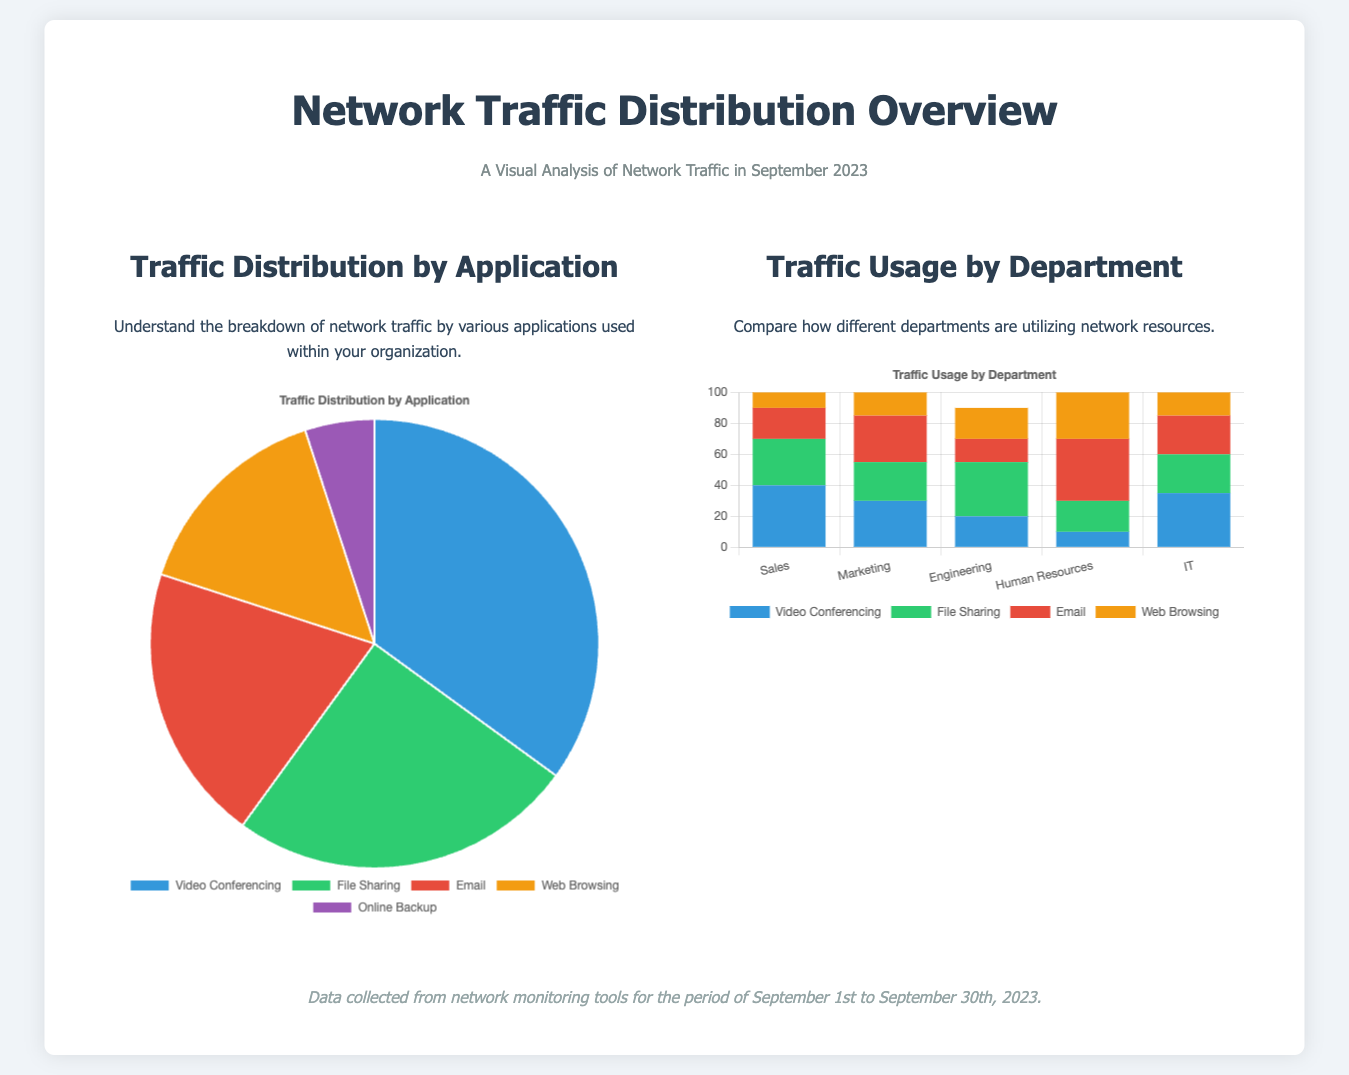what was the total traffic percentage for video conferencing? The traffic percentage for video conferencing is given in the pie chart as 35%.
Answer: 35% which department used the most bandwidth for file sharing? The bar chart shows that the Engineering department had the highest usage for file sharing at 35%.
Answer: Engineering what percentage of traffic was attributed to email? In the pie chart, email accounts for 20% of the traffic distribution.
Answer: 20% how much traffic did the Sales department generate for video conferencing? According to the bar chart, the Sales department generated 40 for video conferencing.
Answer: 40 what application received the least traffic in the distribution? The pie chart indicates that online backup received the least traffic at 5%.
Answer: 5% which department had the highest total traffic usage across all applications? By evaluating the bar chart, the Marketing department had the highest total traffic usage across all applications at 30 for video conferencing, 25 for file sharing, 30 for email, and 15 for web browsing.
Answer: Marketing how many applications are represented in the traffic distribution pie chart? The pie chart lists five different applications representing the traffic distribution.
Answer: Five what color represents email in the bar chart? In the bar chart, email is represented by the color red.
Answer: Red 